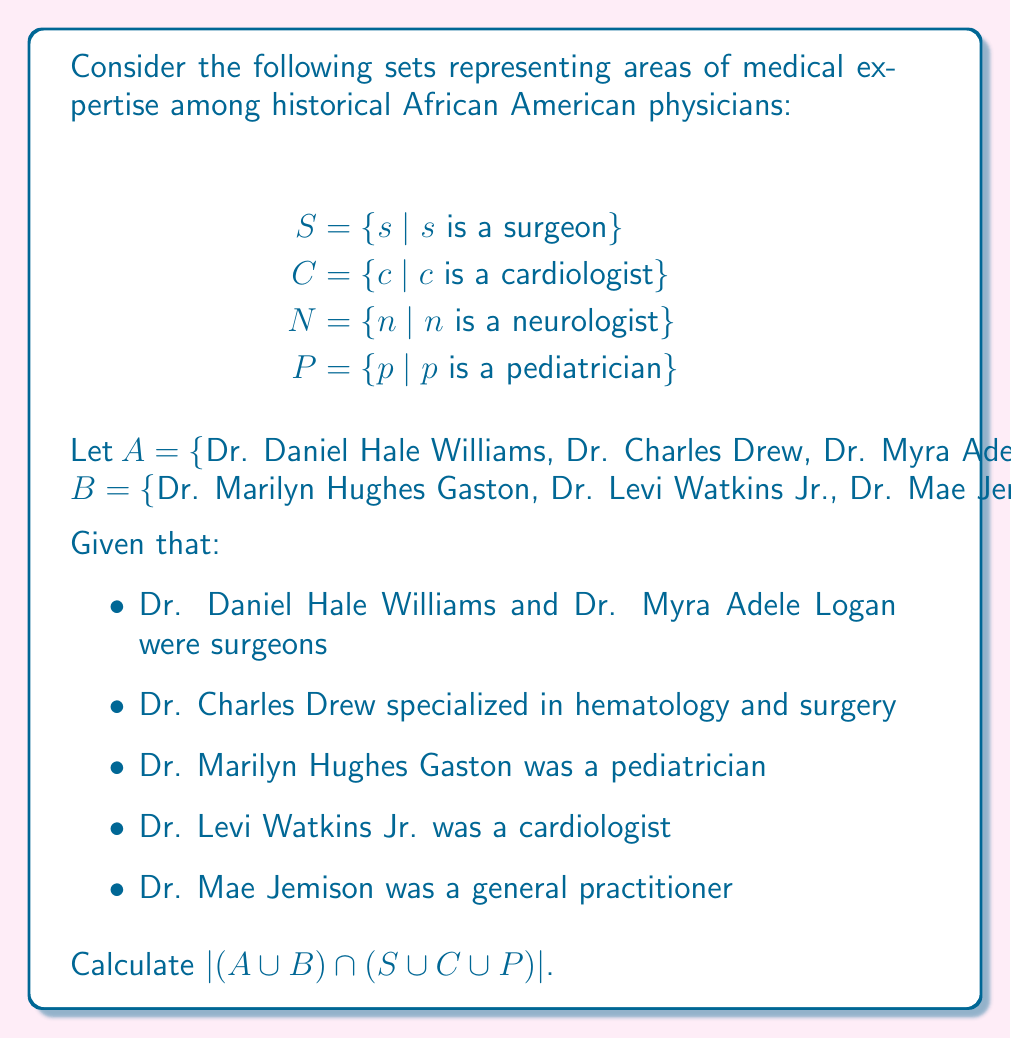What is the answer to this math problem? To solve this problem, we need to follow these steps:

1) First, let's identify which physicians belong to which medical specialties:

   $S = \{Dr. Daniel Hale Williams, Dr. Myra Adele Logan, Dr. Charles Drew\}$
   $C = \{Dr. Levi Watkins Jr.\}$
   $P = \{Dr. Marilyn Hughes Gaston\}$

2) Now, let's find $A \cup B$:
   $A \cup B = \{Dr. Daniel Hale Williams, Dr. Charles Drew, Dr. Myra Adele Logan, Dr. Marilyn Hughes Gaston, Dr. Levi Watkins Jr., Dr. Mae Jemison\}$

3) Next, we need to find $S \cup C \cup P$:
   $S \cup C \cup P = \{Dr. Daniel Hale Williams, Dr. Myra Adele Logan, Dr. Charles Drew, Dr. Levi Watkins Jr., Dr. Marilyn Hughes Gaston\}$

4) Now, we need to find the intersection of these two sets:
   $(A \cup B) \cap (S \cup C \cup P) = \{Dr. Daniel Hale Williams, Dr. Charles Drew, Dr. Myra Adele Logan, Dr. Marilyn Hughes Gaston, Dr. Levi Watkins Jr.\}$

5) Finally, we need to count the number of elements in this set:
   $|(A \cup B) \cap (S \cup C \cup P)| = 5$

Note that Dr. Mae Jemison, being a general practitioner, is not included in the final set as she doesn't belong to $S$, $C$, or $P$.
Answer: $|(A \cup B) \cap (S \cup C \cup P)| = 5$ 